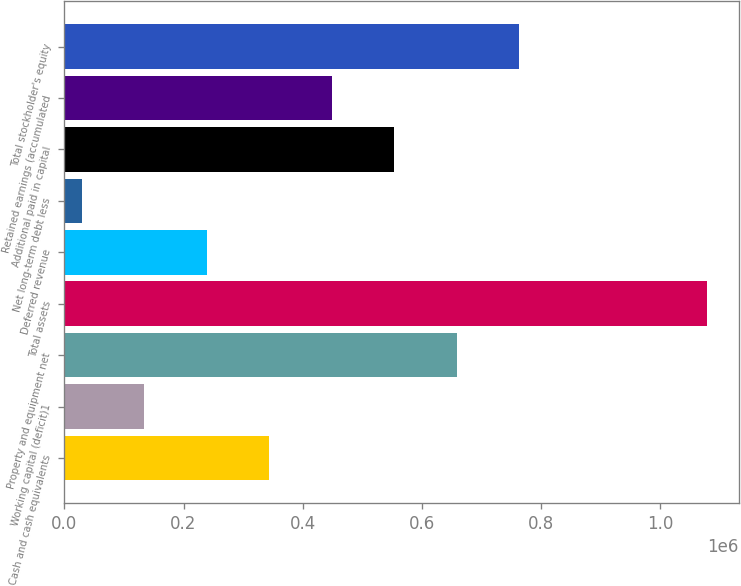Convert chart to OTSL. <chart><loc_0><loc_0><loc_500><loc_500><bar_chart><fcel>Cash and cash equivalents<fcel>Working capital (deficit)1<fcel>Property and equipment net<fcel>Total assets<fcel>Deferred revenue<fcel>Net long-term debt less<fcel>Additional paid in capital<fcel>Retained earnings (accumulated<fcel>Total stockholder's equity<nl><fcel>343682<fcel>133701<fcel>658652<fcel>1.07861e+06<fcel>238691<fcel>28711<fcel>553662<fcel>448672<fcel>763642<nl></chart> 